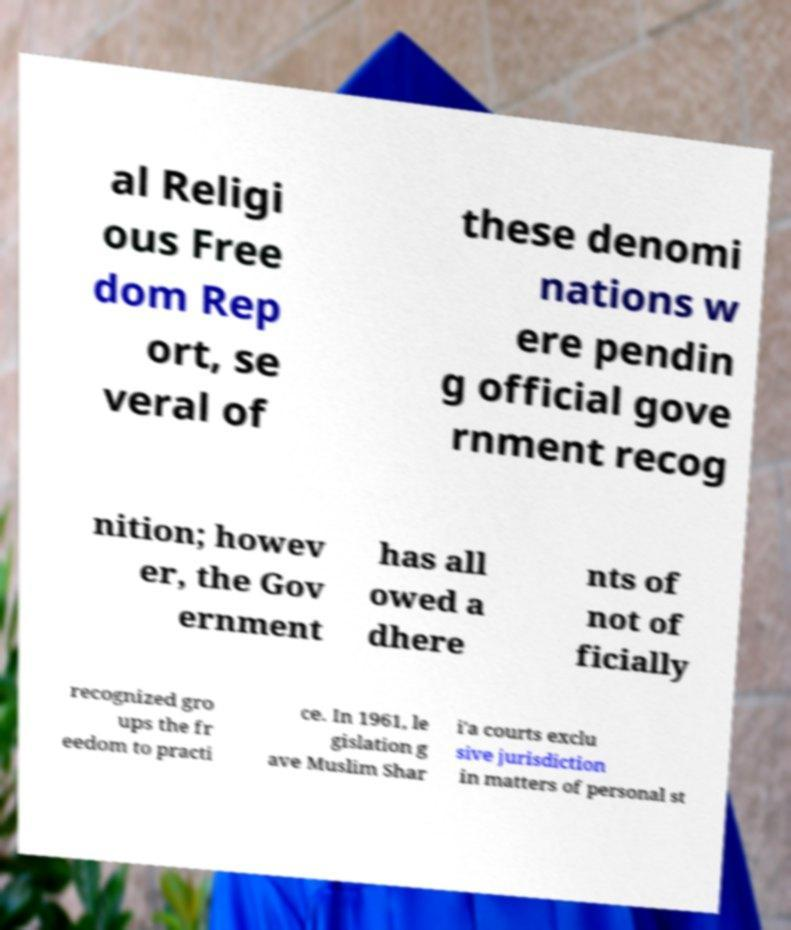Can you read and provide the text displayed in the image?This photo seems to have some interesting text. Can you extract and type it out for me? al Religi ous Free dom Rep ort, se veral of these denomi nations w ere pendin g official gove rnment recog nition; howev er, the Gov ernment has all owed a dhere nts of not of ficially recognized gro ups the fr eedom to practi ce. In 1961, le gislation g ave Muslim Shar i'a courts exclu sive jurisdiction in matters of personal st 